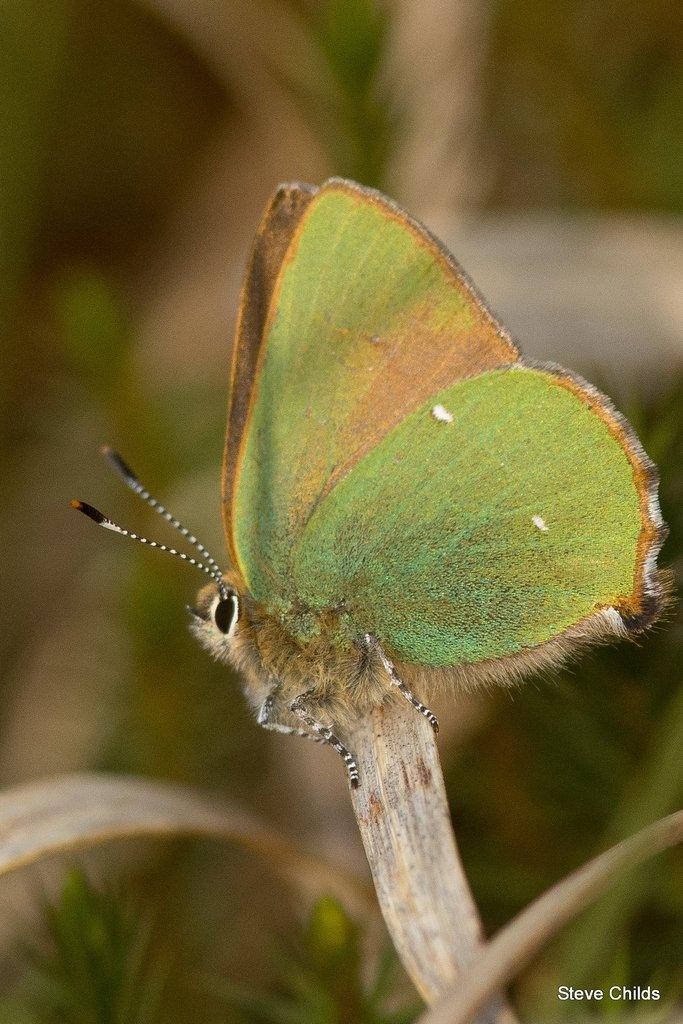What type of insect is in the image? There is a green color butterfly in the image. What is the butterfly standing on? The butterfly is standing on a leaf. What can be seen in the background of the image? There are plants visible in the image. Is there any additional information or marking in the image? Yes, there is a watermark in the bottom right corner of the image. What type of fish can be seen swimming in the image? There is no fish present in the image; it features a green color butterfly standing on a leaf. 